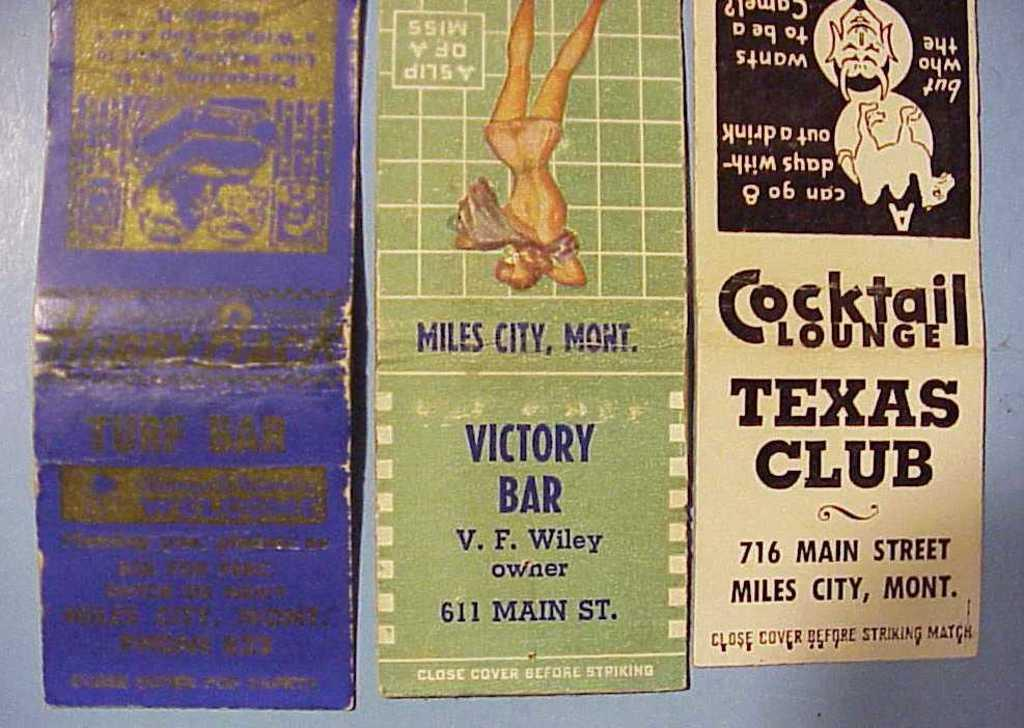<image>
Relay a brief, clear account of the picture shown. Matchbook advertisements for places such as Victory Bar and Texas Club 